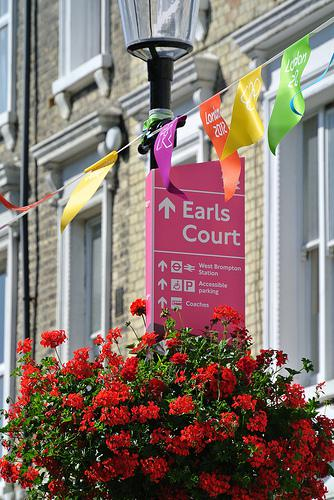Question: who is in the photo?
Choices:
A. Nobody.
B. Noone.
C. Nothing.
D. People.
Answer with the letter. Answer: A Question: what color is the sign?
Choices:
A. Red.
B. Yellow.
C. Pink.
D. White.
Answer with the letter. Answer: C Question: where is the sign?
Choices:
A. On the light.
B. On the lamp post.
C. On the pole.
D. On the post.
Answer with the letter. Answer: B Question: what color are the flowers?
Choices:
A. Pink.
B. White.
C. Red.
D. Orange.
Answer with the letter. Answer: C Question: what kind of building is it?
Choices:
A. Stone.
B. Wood.
C. Rock.
D. Brick.
Answer with the letter. Answer: D Question: what is hanging from the line?
Choices:
A. Shoes.
B. Clothes.
C. Flags.
D. Sheets.
Answer with the letter. Answer: C Question: how many windows are there?
Choices:
A. 4.
B. 7.
C. 2.
D. 8.
Answer with the letter. Answer: B 